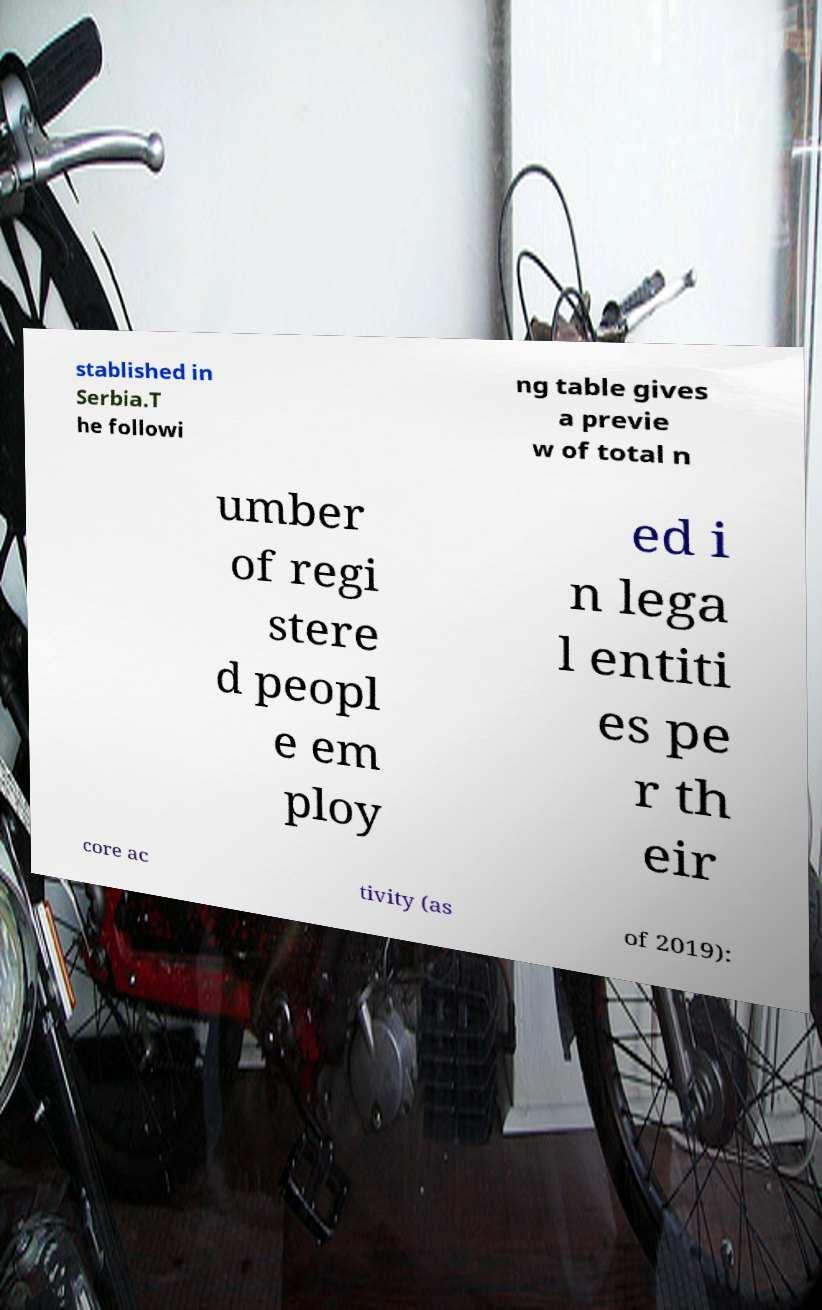Could you extract and type out the text from this image? stablished in Serbia.T he followi ng table gives a previe w of total n umber of regi stere d peopl e em ploy ed i n lega l entiti es pe r th eir core ac tivity (as of 2019): 